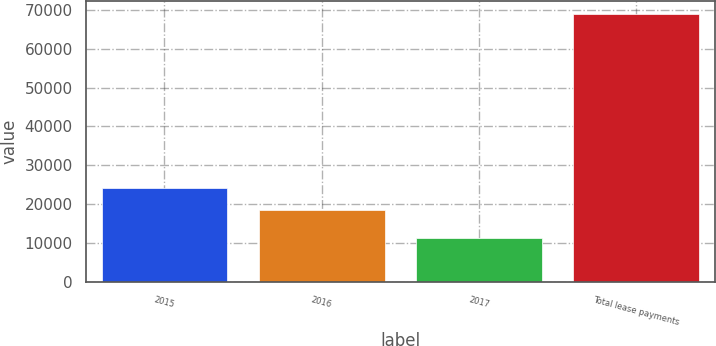Convert chart to OTSL. <chart><loc_0><loc_0><loc_500><loc_500><bar_chart><fcel>2015<fcel>2016<fcel>2017<fcel>Total lease payments<nl><fcel>24173.8<fcel>18415<fcel>11384<fcel>68972<nl></chart> 